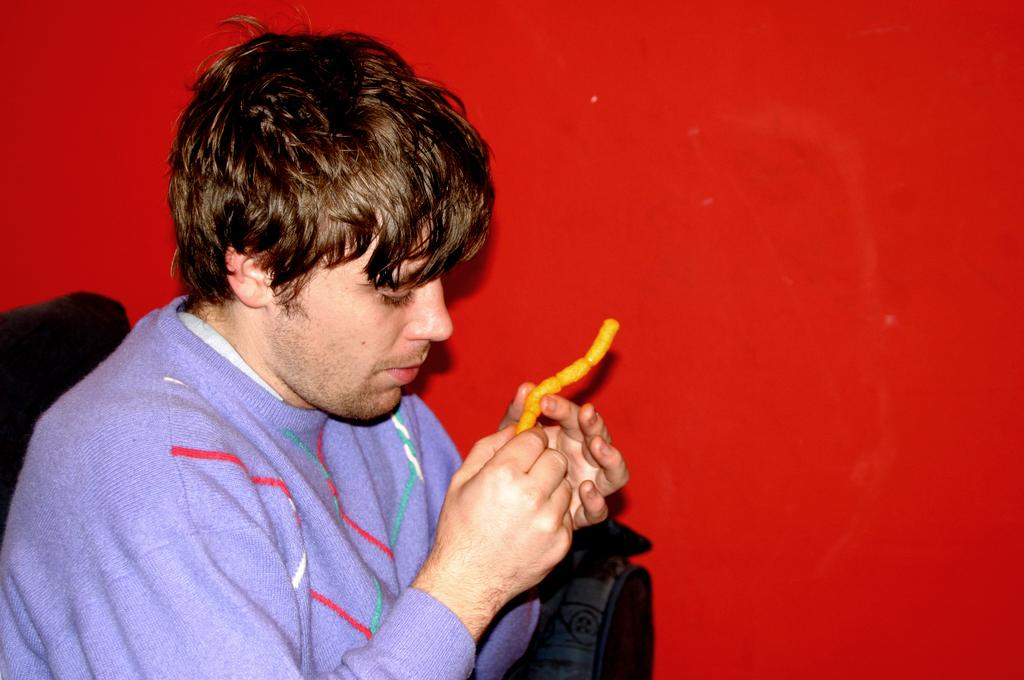What is the person in the image doing? There is a person sitting on a couch in the image. What is the person holding in his hand? The person is holding an object in his hand. Can you describe the color of the wall in the image? There is a wall with red color in the image. What type of berry is the person eating in the image? There is no berry present in the image, and the person is not eating anything. 